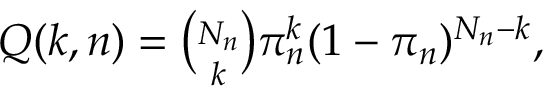Convert formula to latex. <formula><loc_0><loc_0><loc_500><loc_500>\begin{array} { r } { Q ( k , n ) = \binom { N _ { n } } { k } \pi _ { n } ^ { k } ( 1 - \pi _ { n } ) ^ { N _ { n } - k } , } \end{array}</formula> 